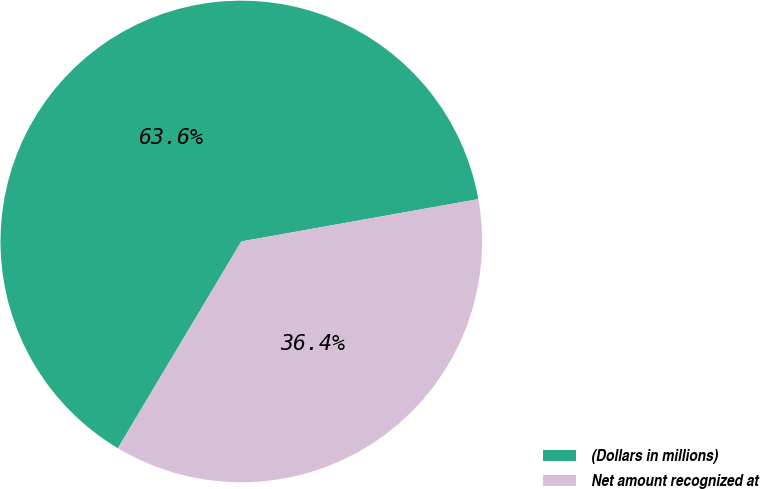<chart> <loc_0><loc_0><loc_500><loc_500><pie_chart><fcel>(Dollars in millions)<fcel>Net amount recognized at<nl><fcel>63.62%<fcel>36.38%<nl></chart> 